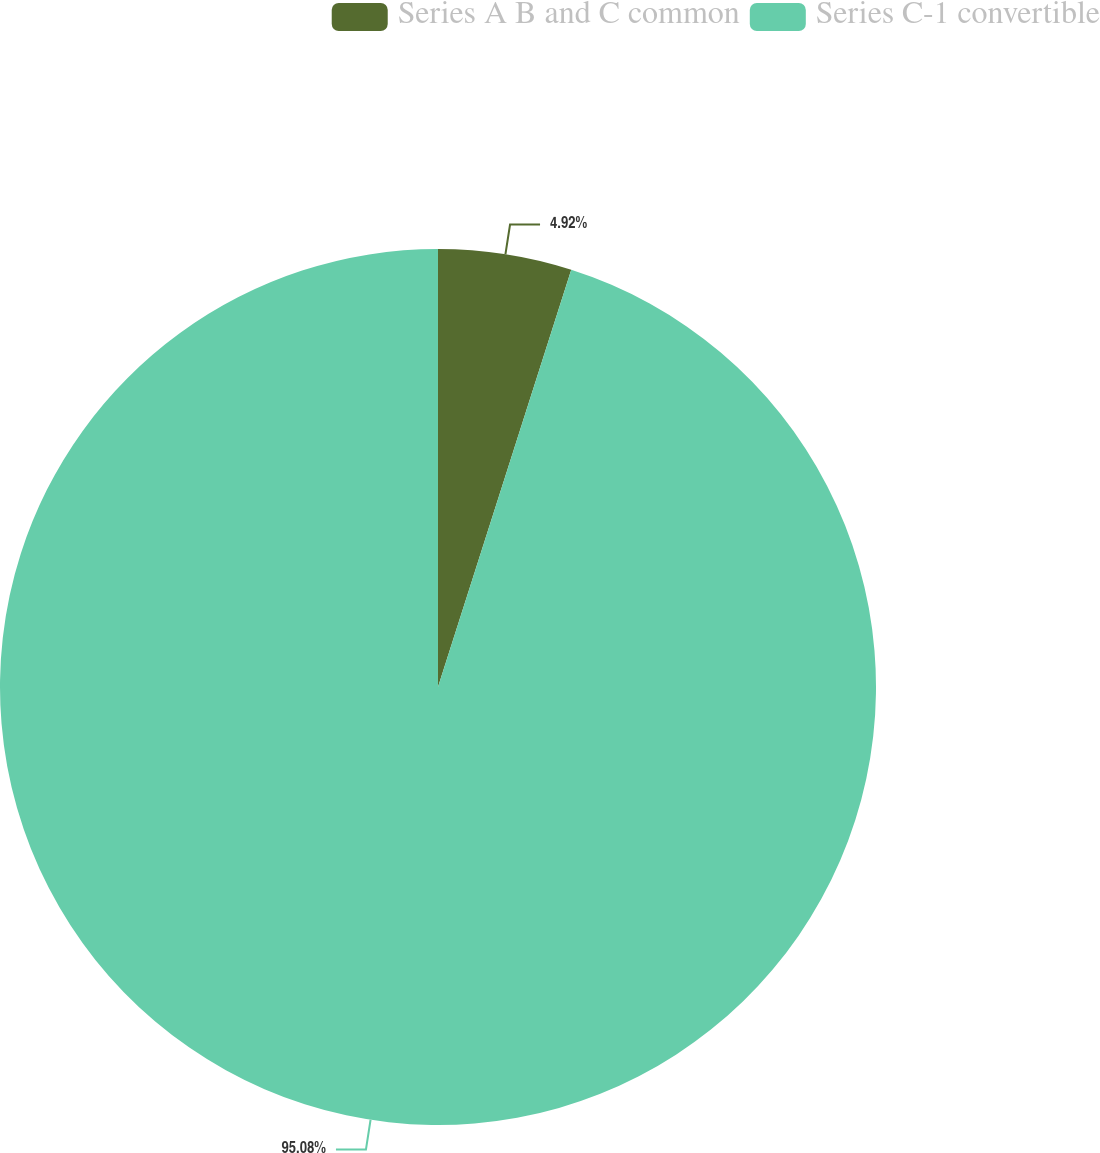Convert chart. <chart><loc_0><loc_0><loc_500><loc_500><pie_chart><fcel>Series A B and C common<fcel>Series C-1 convertible<nl><fcel>4.92%<fcel>95.08%<nl></chart> 